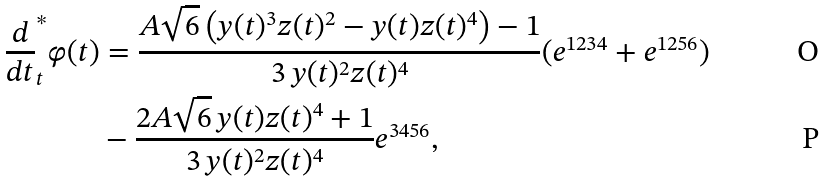Convert formula to latex. <formula><loc_0><loc_0><loc_500><loc_500>\frac { d } { d t } ^ { * } _ { t } \varphi ( t ) & = \frac { A \sqrt { 6 } \left ( y ( t ) ^ { 3 } z ( t ) ^ { 2 } - y ( t ) z ( t ) ^ { 4 } \right ) - 1 } { 3 \, y ( t ) ^ { 2 } z ( t ) ^ { 4 } } ( e ^ { 1 2 3 4 } + e ^ { 1 2 5 6 } ) \\ & - \frac { 2 A \sqrt { 6 } \, y ( t ) z ( t ) ^ { 4 } + 1 } { 3 \, y ( t ) ^ { 2 } z ( t ) ^ { 4 } } e ^ { 3 4 5 6 } ,</formula> 